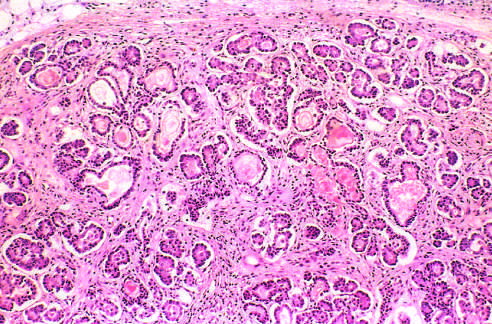re the parenchymal glands atrophic and replaced by fibrous tissue?
Answer the question using a single word or phrase. Yes 